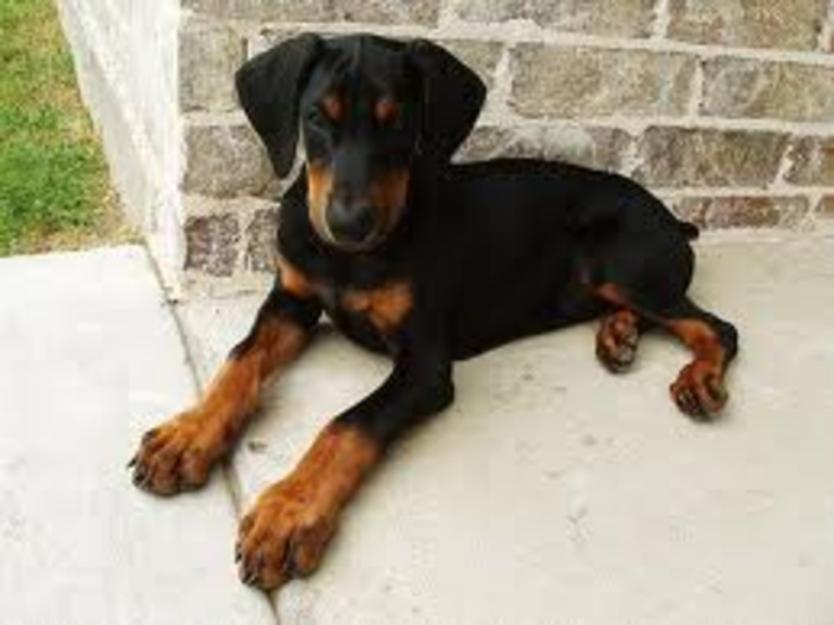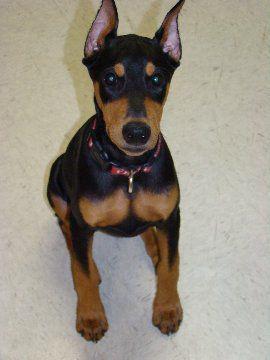The first image is the image on the left, the second image is the image on the right. Assess this claim about the two images: "In the right image, there's a Doberman sitting down.". Correct or not? Answer yes or no. Yes. 